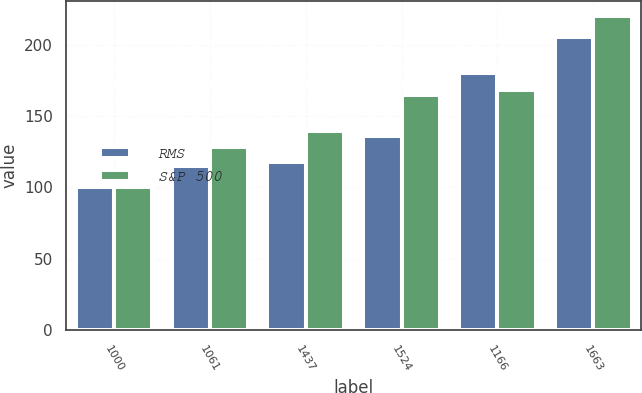Convert chart to OTSL. <chart><loc_0><loc_0><loc_500><loc_500><stacked_bar_chart><ecel><fcel>1000<fcel>1061<fcel>1437<fcel>1524<fcel>1166<fcel>1663<nl><fcel>RMS<fcel>100<fcel>115.1<fcel>117.5<fcel>136.3<fcel>180.4<fcel>205.1<nl><fcel>S&P 500<fcel>100<fcel>128.5<fcel>139.6<fcel>164.5<fcel>168.5<fcel>219.7<nl></chart> 